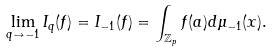Convert formula to latex. <formula><loc_0><loc_0><loc_500><loc_500>\lim _ { q \to - 1 } I _ { q } ( f ) = I _ { - 1 } ( f ) = \int _ { \mathbb { Z } _ { p } } f ( a ) d \mu _ { - 1 } ( x ) .</formula> 